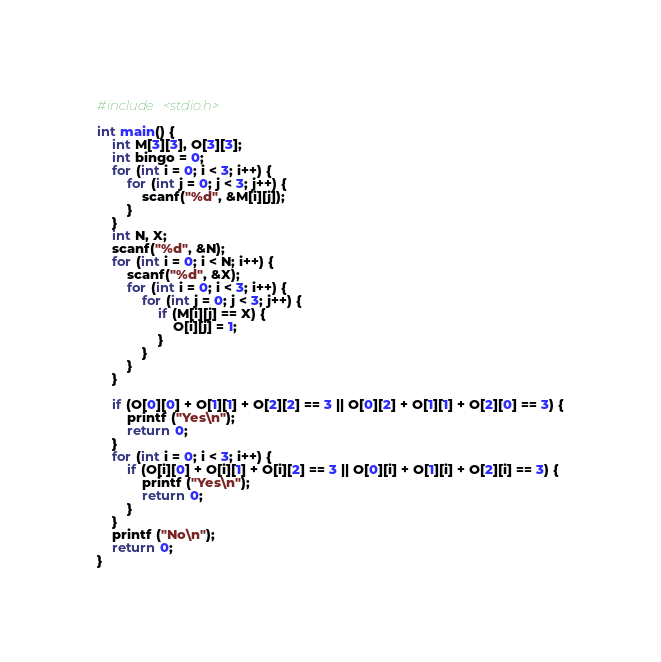Convert code to text. <code><loc_0><loc_0><loc_500><loc_500><_C_>#include <stdio.h>

int main() {
	int M[3][3], O[3][3];
	int bingo = 0;
	for (int i = 0; i < 3; i++) {
		for (int j = 0; j < 3; j++) {
			scanf("%d", &M[i][j]);
		}
	}
	int N, X;
	scanf("%d", &N);
	for (int i = 0; i < N; i++) {
		scanf("%d", &X);
	    for (int i = 0; i < 3; i++) {
		    for (int j = 0; j < 3; j++) {
		        if (M[i][j] == X) {
		        	O[i][j] = 1;
	            }
            }
		}
	}
	
	if (O[0][0] + O[1][1] + O[2][2] == 3 || O[0][2] + O[1][1] + O[2][0] == 3) {
		printf ("Yes\n");
		return 0;
	}
	for (int i = 0; i < 3; i++) {
		if (O[i][0] + O[i][1] + O[i][2] == 3 || O[0][i] + O[1][i] + O[2][i] == 3) {
			printf ("Yes\n");
			return 0;
		}
	}
	printf ("No\n");
	return 0;
}</code> 